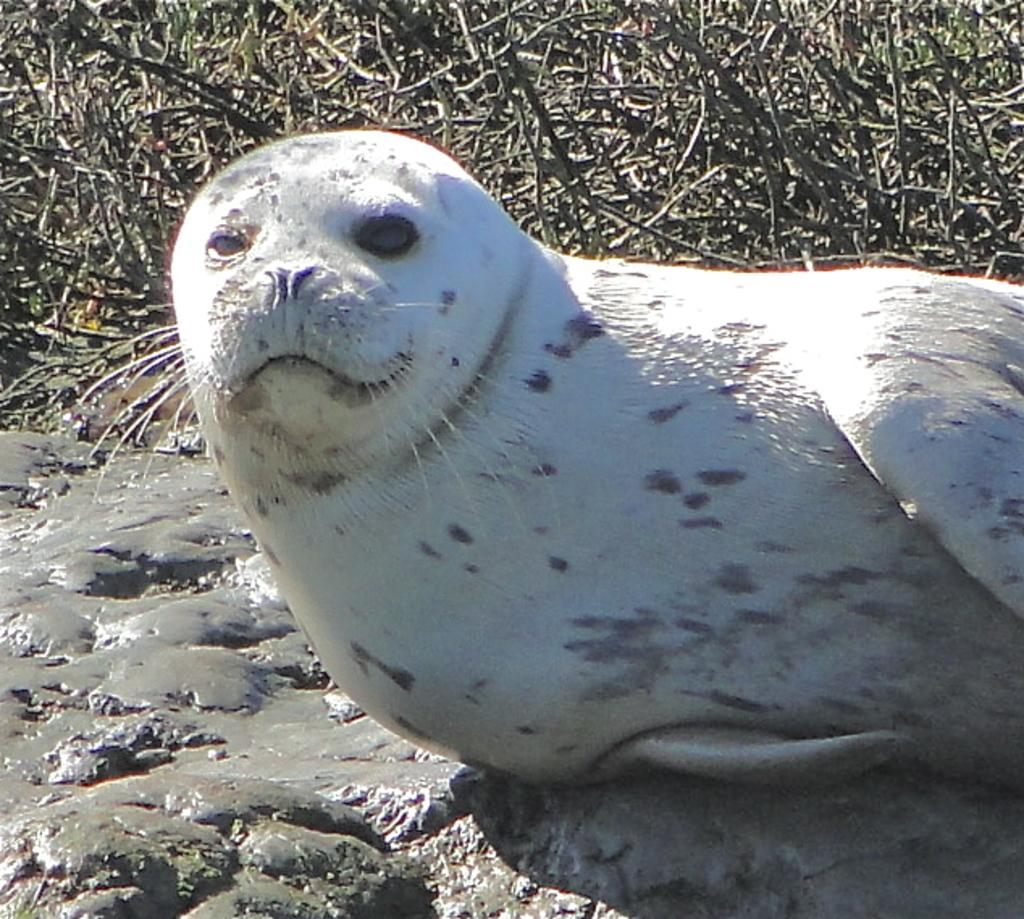What animal is in the center of the image? There is a seal in the center of the image. What is located at the bottom of the image? There is a rock at the bottom of the image. What type of vegetation can be seen in the background of the image? There are twigs visible in the background of the image. What type of knife is being used by the friends in the meeting in the image? There is no meeting or friends present in the image, and therefore no knife can be observed. 